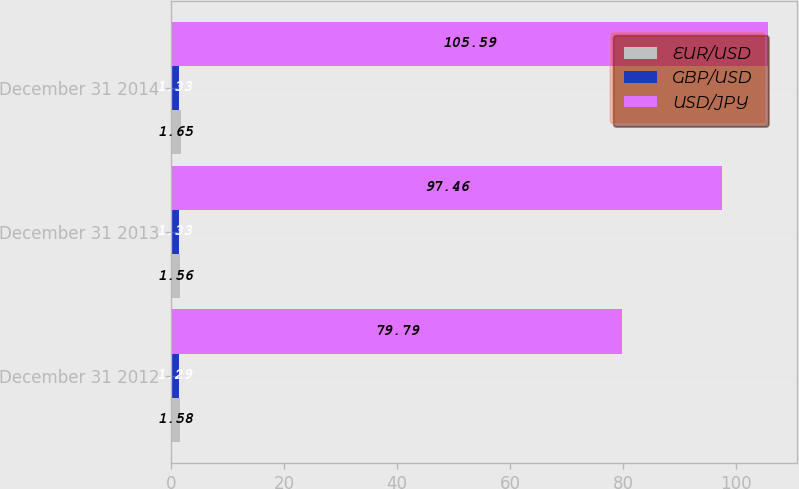Convert chart. <chart><loc_0><loc_0><loc_500><loc_500><stacked_bar_chart><ecel><fcel>December 31 2012<fcel>December 31 2013<fcel>December 31 2014<nl><fcel>EUR/USD<fcel>1.58<fcel>1.56<fcel>1.65<nl><fcel>GBP/USD<fcel>1.29<fcel>1.33<fcel>1.33<nl><fcel>USD/JPY<fcel>79.79<fcel>97.46<fcel>105.59<nl></chart> 